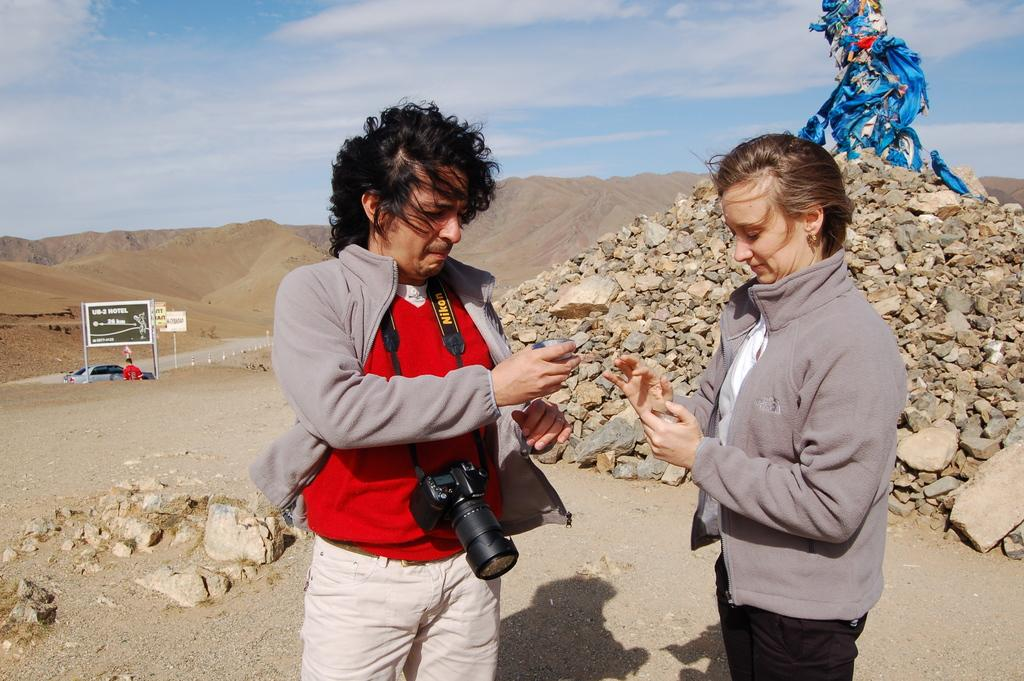How many people are in the image? There are people in the image, but the exact number is not specified. What is one person wearing in the image? One person is wearing a camera in the image. What type of natural features can be seen in the image? There are stones visible in the image, and sand hills can be seen in the background. What type of slip is the person wearing on their feet in the image? There is no information about the person's footwear in the image, so it cannot be determined if they are wearing a slip or any other type of footwear. 